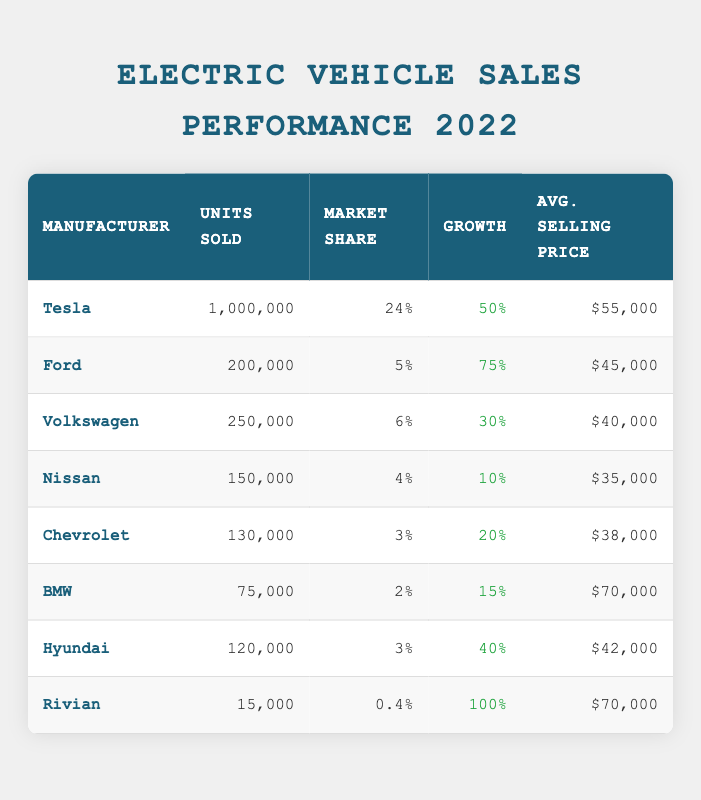What was Tesla's market share in 2022? According to the table, Tesla's market share in 2022 is listed as 24%.
Answer: 24% Which manufacturer experienced the highest percentage growth in sales? By comparing the percentage growth for each manufacturer, Rivian has a growth rate of 100%, which is the highest among all the manufacturers listed.
Answer: Rivian What is the total number of units sold by all manufacturers combined? To find the total units sold, we need to add the units sold by each manufacturer: 1000000 + 200000 + 250000 + 150000 + 130000 + 75000 + 120000 + 15000 = 1,400,000.
Answer: 1,400,000 Is Chevrolet's average selling price higher than Ford's? The average selling price for Chevrolet is $38,000, while for Ford it is $45,000. Since $38,000 is less than $45,000, the statement is false.
Answer: No What is the average number of units sold by the listed manufacturers? To find the average, we sum the units sold: 1000000 + 200000 + 250000 + 150000 + 130000 + 75000 + 120000 + 15000 = 1,400,000. There are 8 rows (manufacturers), so the average is 1,400,000 / 8 = 175,000.
Answer: 175,000 How many manufacturers sold more than 100,000 units? From the table, the manufacturers selling more than 100,000 units are Tesla (1,000,000), Ford (200,000), Volkswagen (250,000), and Nissan (150,000). This gives a total of 4 manufacturers.
Answer: 4 Which manufacturer has the highest average selling price, and what is it? By examining the average selling prices, BMW and Rivian both have the highest price of $70,000. Thus, both manufacturers tie for the highest selling price.
Answer: BMW and Rivian, $70,000 Did Honda sell electric vehicles in 2022 according to this table? Honda is not listed as one of the manufacturers in the table, therefore the answer is no.
Answer: No 